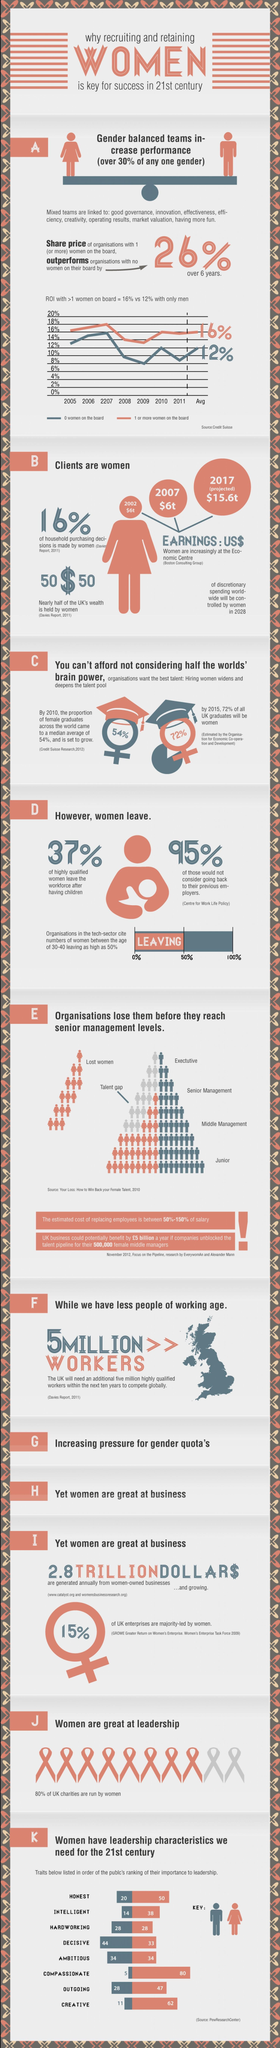Overall who have more leadership traits, men or women?
Answer the question with a short phrase. Women What % of the women workforce wouldn't consider going back to the previous employers? 95% Which is the weakest leadership trait in men? Compassionate How many more workers will UK need, to meet the Global competition over the next decade? 5 million What percentage of the women workforce leave after having children? 37% Who are more intelligent, men or women? Women Which are the 2 top levels of organisational hierarchy? Executive, senior management Who are more outgoing, men or women? Women In which two leadership traits are both men and women equal? Hardworking, ambitious Which is the lowest level of organisational hierarchy? Junior What is the cost of filling the talent gap? 50%-150% of salary Who are more creative, men or women? Women Which are the two strongest leadership traits in men? decisive, ambitious In which three senior management levels, do organisations lose their female employees? Executive, senior management, middle management Who is more honest, men or women? Women Which is the weakest leadership trait in women? Hardworking How many leadership traits are listed here? 8 Which is the only leadership trait in which men are stronger than women? decisive What percent of UK charities are not run by women? 20% Which are the three strongest leadership traits in women? Compassionate, creative, honest What percentage of women in the Tech sector leave their jobs? 50% 